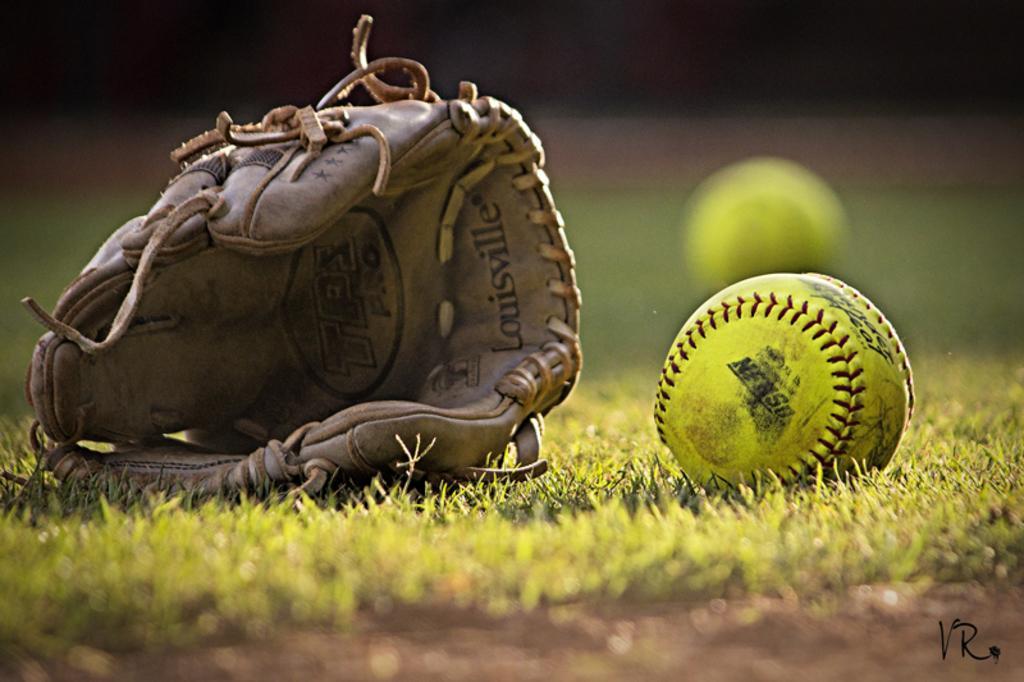Could you give a brief overview of what you see in this image? In this image I can see grass ground and on it I can see two green colour balls and a baseball glove. I can also see something is written on the glove and on the bottom right side of the image I can see a watermark. I can also see this image is little bit blurry in the background. 